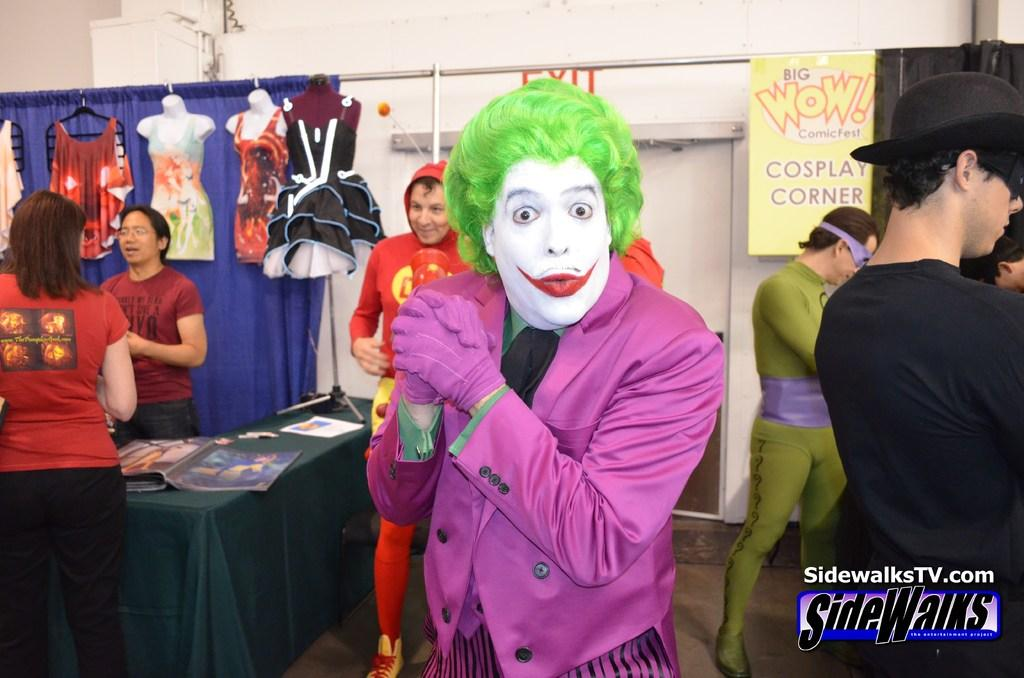<image>
Share a concise interpretation of the image provided. The joker standing in front of a sign that has Wow outlined in red. 